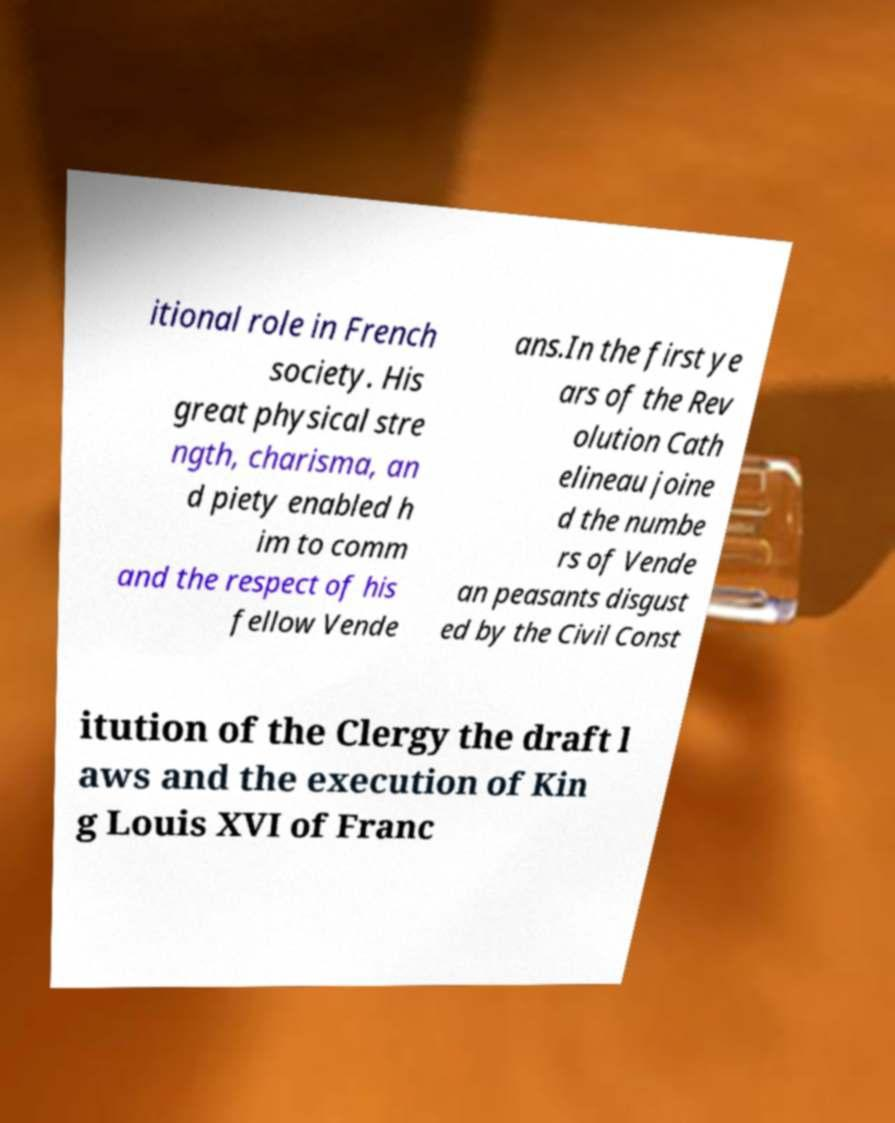Can you accurately transcribe the text from the provided image for me? itional role in French society. His great physical stre ngth, charisma, an d piety enabled h im to comm and the respect of his fellow Vende ans.In the first ye ars of the Rev olution Cath elineau joine d the numbe rs of Vende an peasants disgust ed by the Civil Const itution of the Clergy the draft l aws and the execution of Kin g Louis XVI of Franc 